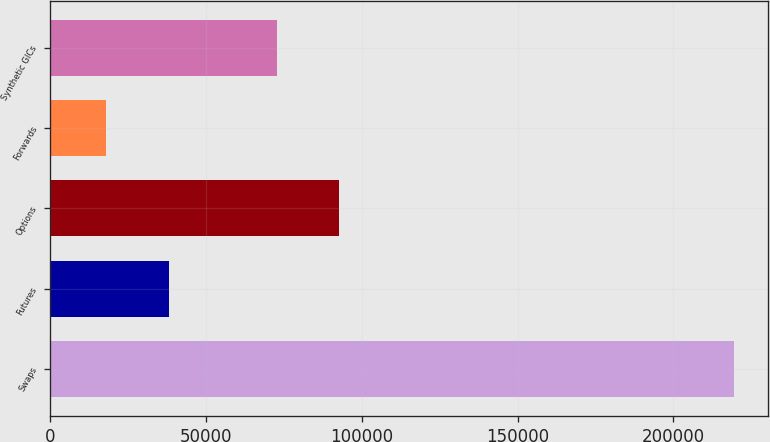Convert chart to OTSL. <chart><loc_0><loc_0><loc_500><loc_500><bar_chart><fcel>Swaps<fcel>Futures<fcel>Options<fcel>Forwards<fcel>Synthetic GICs<nl><fcel>219511<fcel>37979.2<fcel>92755.2<fcel>17809<fcel>72585<nl></chart> 